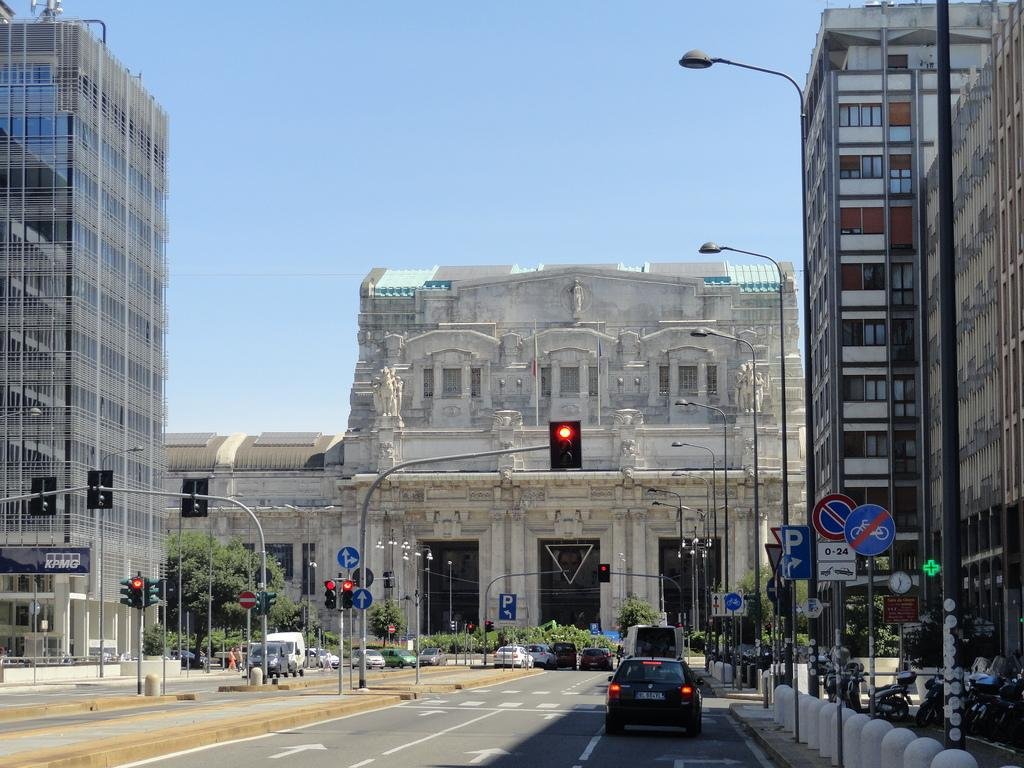What can be seen moving on the roads in the image? There are vehicles on the roads in the image. What structures are present along the roads in the image? There are poles and traffic signal lights in the image. What type of buildings can be seen in the image? There are buildings with windows in the image. What type of vegetation is visible in the image? Trees are visible in the image. What type of signs can be seen in the image? Signboards are present in the image. What is visible in the background of the image? The sky is visible in the background of the image. How many tin balls are rolling on the sidewalk in the image? There are no tin balls present in the image. Can you describe the ladybug sitting on the traffic signal light in the image? There is no ladybug present on the traffic signal light in the image. 